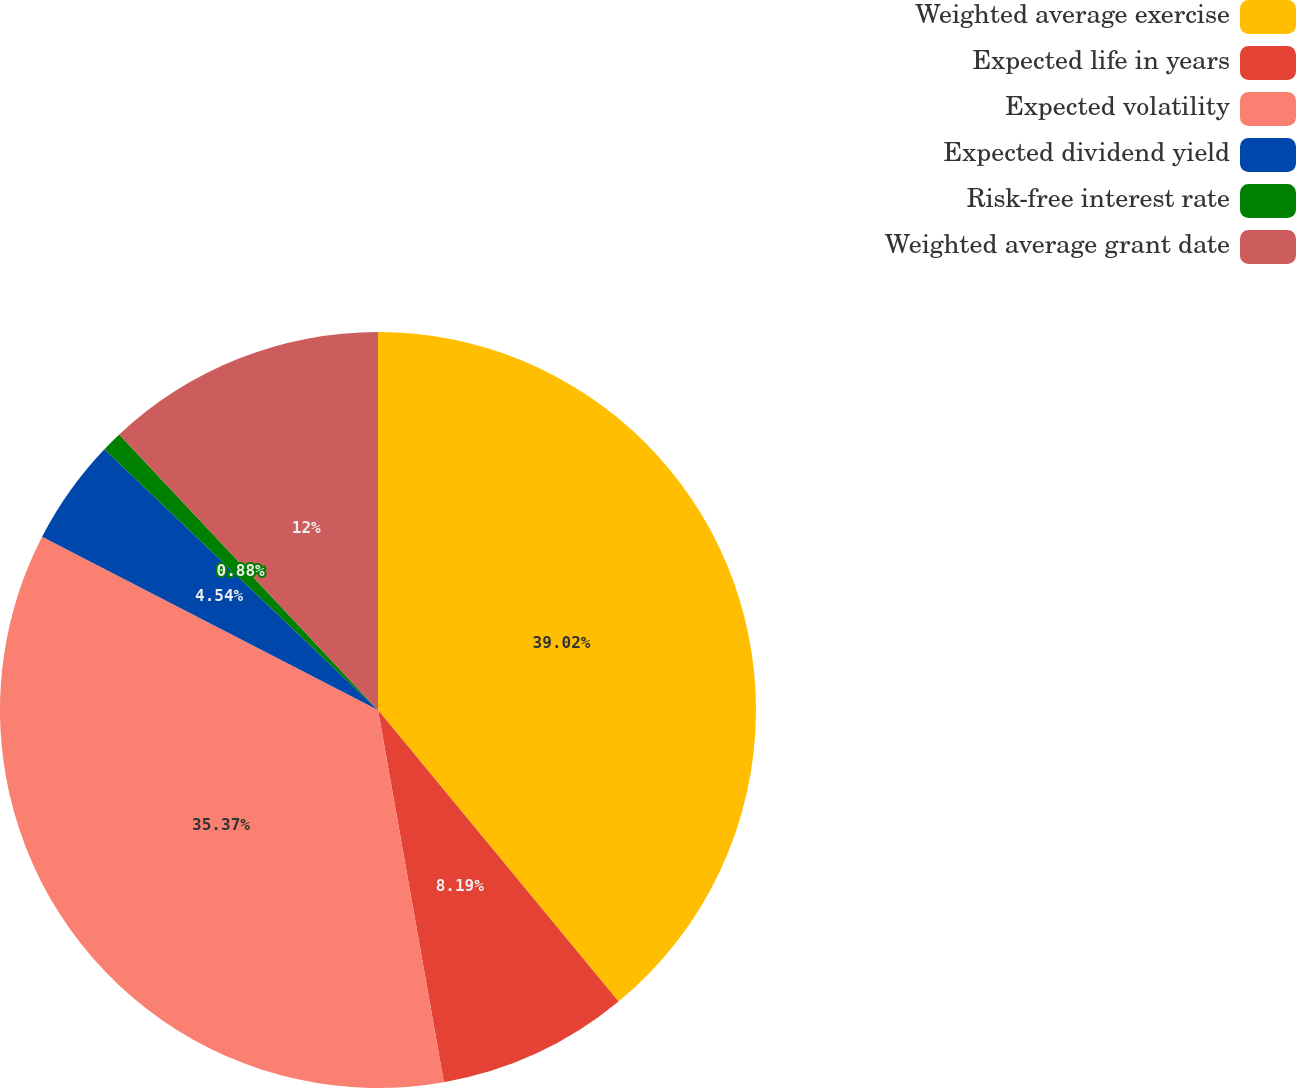Convert chart to OTSL. <chart><loc_0><loc_0><loc_500><loc_500><pie_chart><fcel>Weighted average exercise<fcel>Expected life in years<fcel>Expected volatility<fcel>Expected dividend yield<fcel>Risk-free interest rate<fcel>Weighted average grant date<nl><fcel>39.02%<fcel>8.19%<fcel>35.37%<fcel>4.54%<fcel>0.88%<fcel>12.0%<nl></chart> 